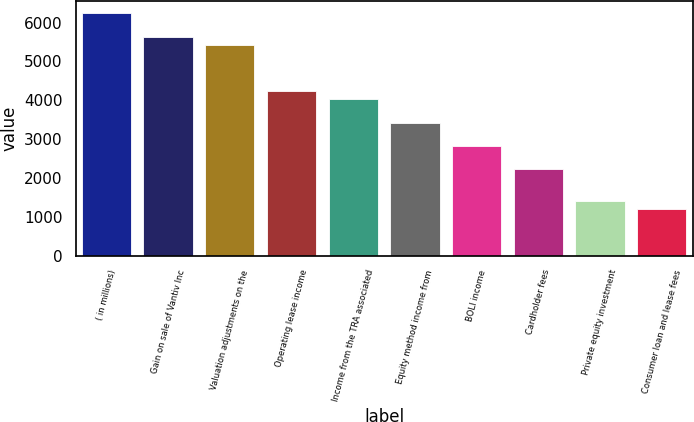<chart> <loc_0><loc_0><loc_500><loc_500><bar_chart><fcel>( in millions)<fcel>Gain on sale of Vantiv Inc<fcel>Valuation adjustments on the<fcel>Operating lease income<fcel>Income from the TRA associated<fcel>Equity method income from<fcel>BOLI income<fcel>Cardholder fees<fcel>Private equity investment<fcel>Consumer loan and lease fees<nl><fcel>6238.1<fcel>5634.8<fcel>5433.7<fcel>4227.1<fcel>4026<fcel>3422.7<fcel>2819.4<fcel>2216.1<fcel>1411.7<fcel>1210.6<nl></chart> 